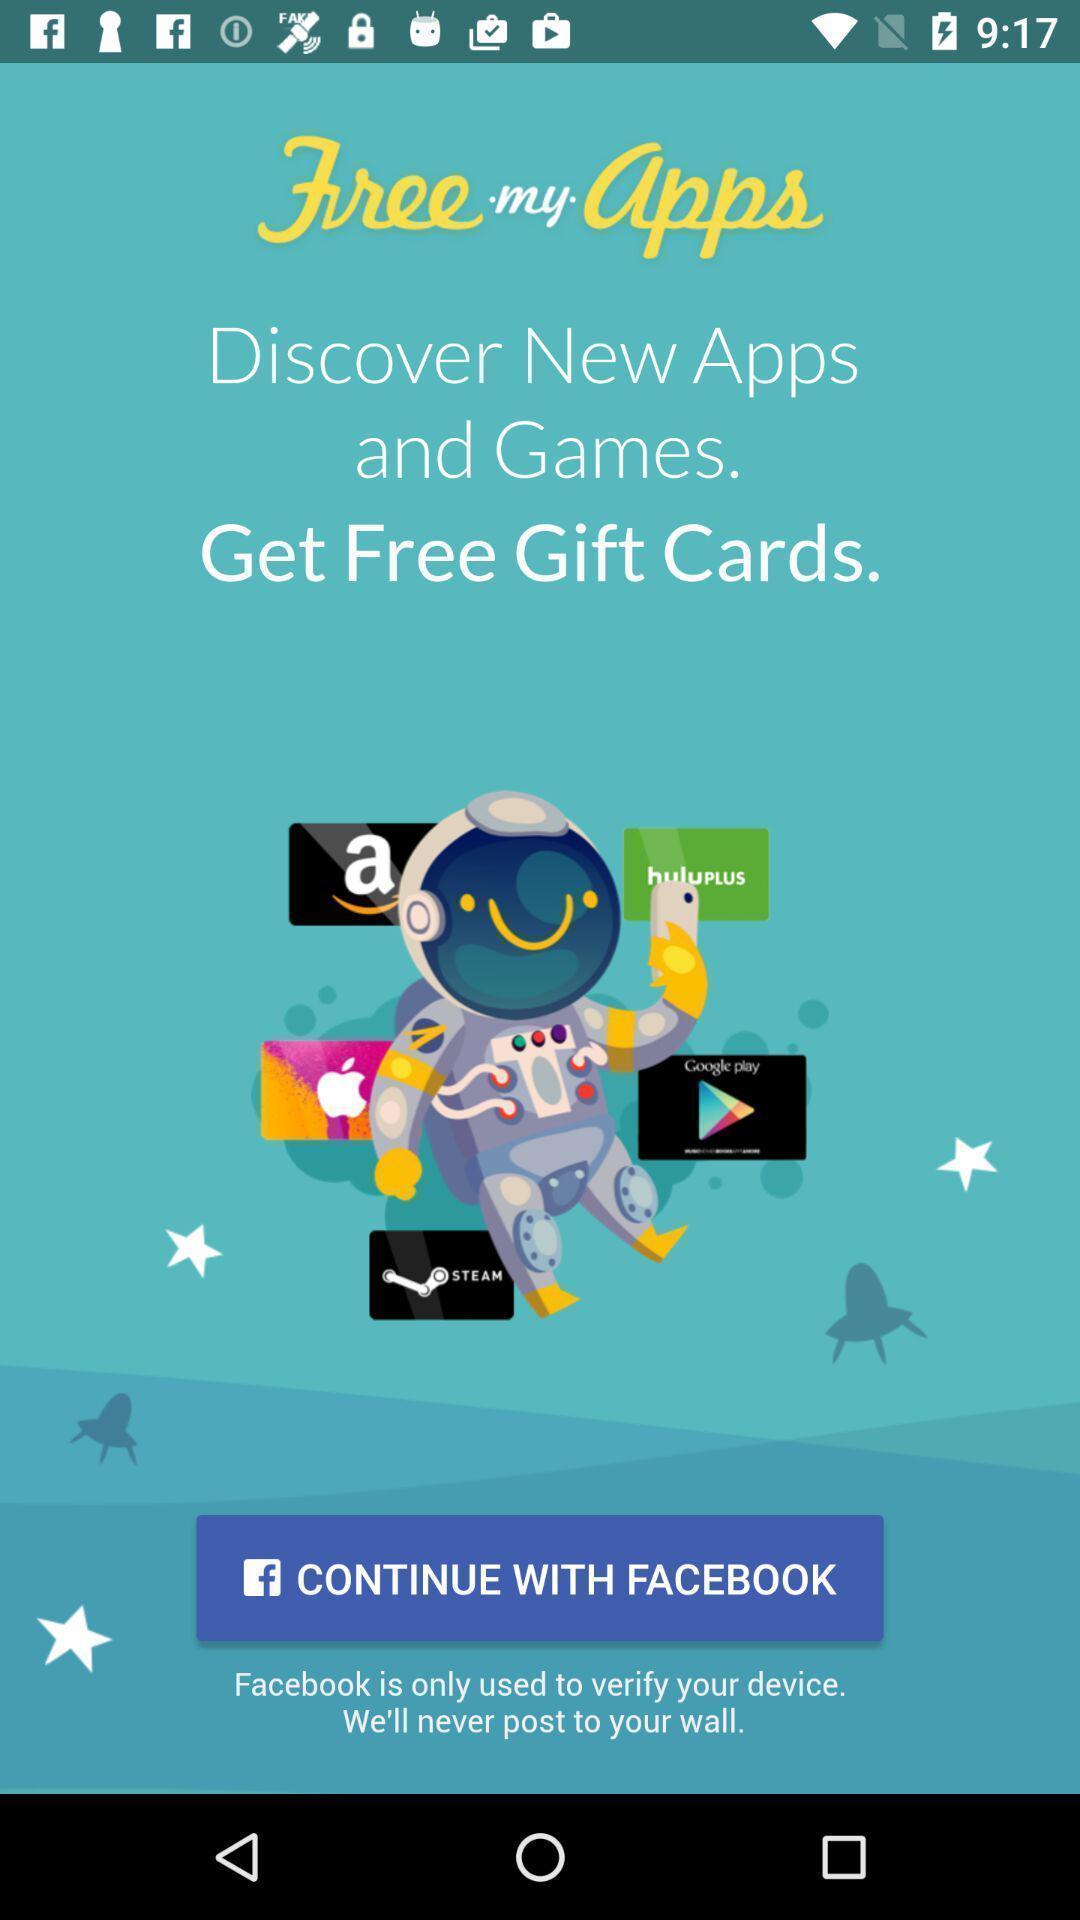Explain what's happening in this screen capture. Welcome page. 